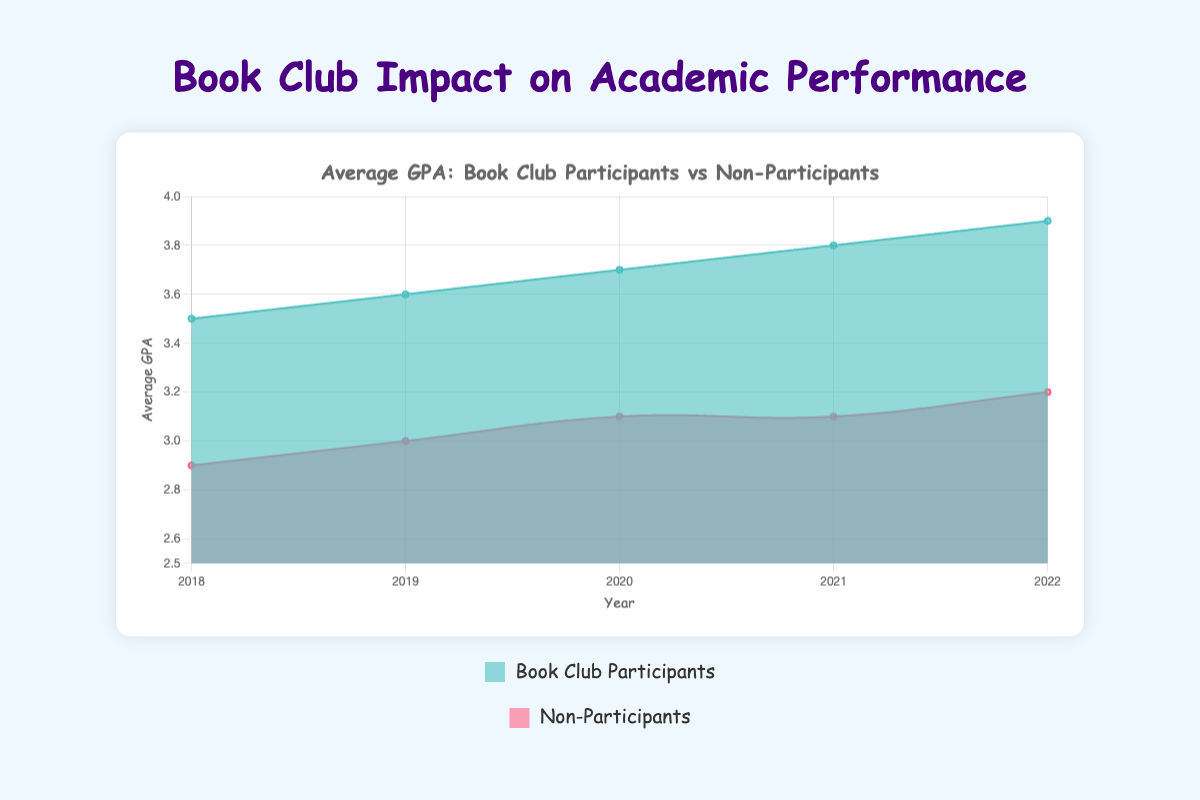What is the title of the chart? The title is displayed at the top of the chart and reads "Average GPA: Book Club Participants vs Non-Participants".
Answer: Average GPA: Book Club Participants vs Non-Participants How did the average GPA of book club participants change from 2018 to 2022? By observing the "Book Club Participants" line from 2018 to 2022, the average GPA increased steadily from 3.5 in 2018 to 3.9 in 2022.
Answer: It increased What is the highest average GPA for non-participants over the years? Looking at the "Non-Participants" line, the highest average GPA is 3.2 in 2022.
Answer: 3.2 In which year did book club participants have a 3.7 average GPA? By observing the "Book Club Participants" line, they had an average GPA of 3.7 in 2020.
Answer: 2020 How does the average GPA in 2022 for book club participants compare with non-participants? In 2022, book club participants had an average GPA of 3.9, while non-participants had an average GPA of 3.2. The book club participants' GPA was higher.
Answer: Book club participants had a higher GPA What is the general trend of the average GPA for non-participants over the five-year period? Observing the "Non-Participants" line, the average GPA shows a steady but gradual increase from 2.9 in 2018 to 3.2 in 2022.
Answer: Gradual increase How many schools are represented in the data? Both book club participants and non-participants have data points for 5 schools: Greenwood High, Riverside School, Sunnyvale School District, Mountainview High, and Lakeside Academy.
Answer: 5 schools What's the difference in average GPA between both groups in 2019? The average GPA for book club participants in 2019 was 3.6, and for non-participants, it was 3.0. The difference is 3.6 - 3.0 = 0.6.
Answer: 0.6 Which group had a greater increase in average GPA from 2018 to 2022? The book club participants' average GPA increased from 3.5 to 3.9, while the non-participants' average GPA increased from 2.9 to 3.2. The difference for participants is 0.4, while for non-participants it is 0.3.
Answer: Book club participants Describe the color of the area representing non-participants. The area representing non-participants is filled with a reddish-pink color.
Answer: Reddish-pink 